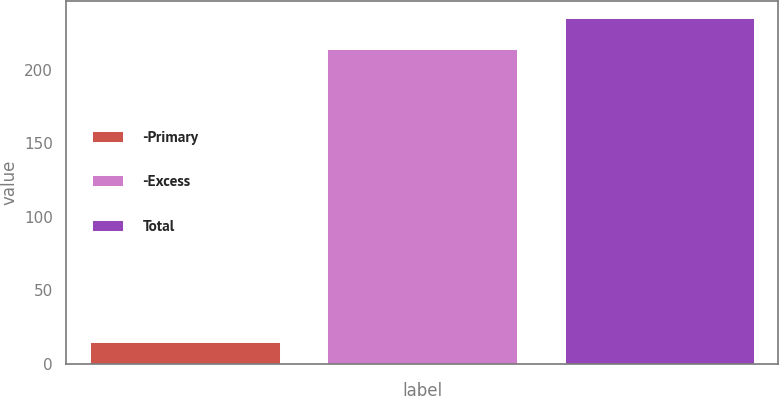<chart> <loc_0><loc_0><loc_500><loc_500><bar_chart><fcel>-Primary<fcel>-Excess<fcel>Total<nl><fcel>15<fcel>214<fcel>235.4<nl></chart> 